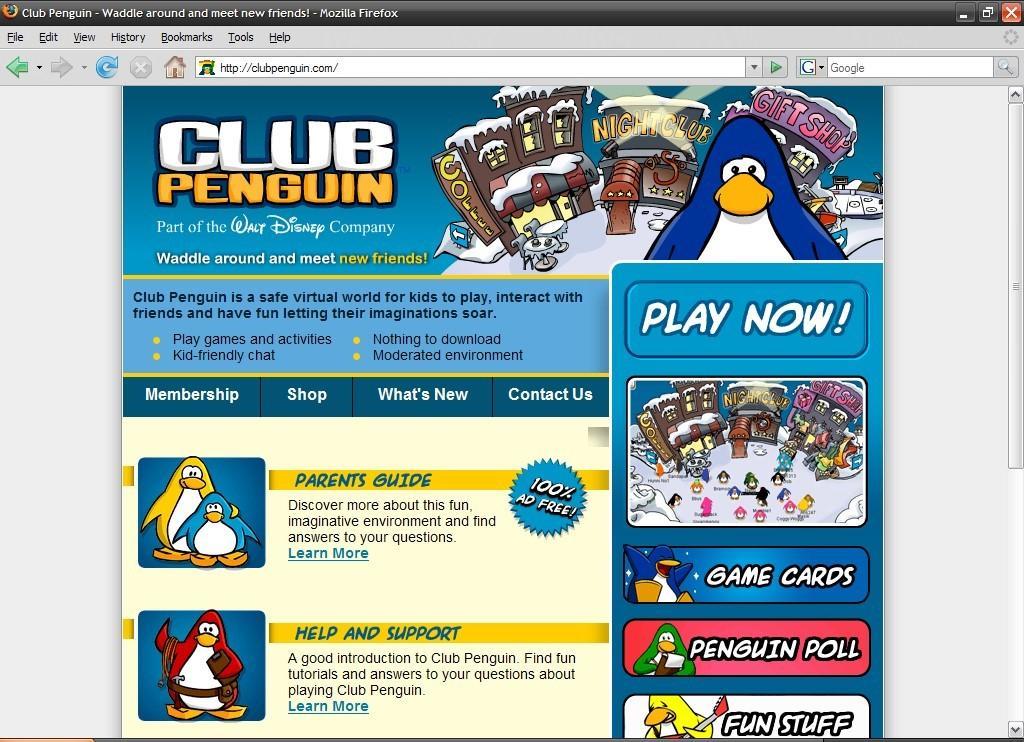How would you summarize this image in a sentence or two? In this picture there is a computer screen or a tab. In the center of the picture there is a poster, in the poster there are cartoons, text. At the top there is text. 